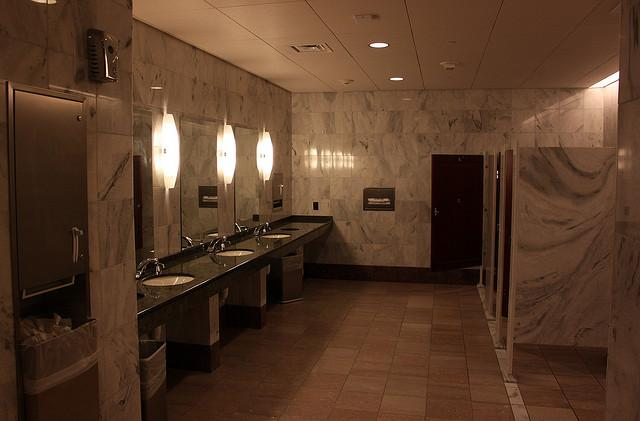Where might this bathroom be? Please explain your reasoning. casino. The bathroom is in a casino. 